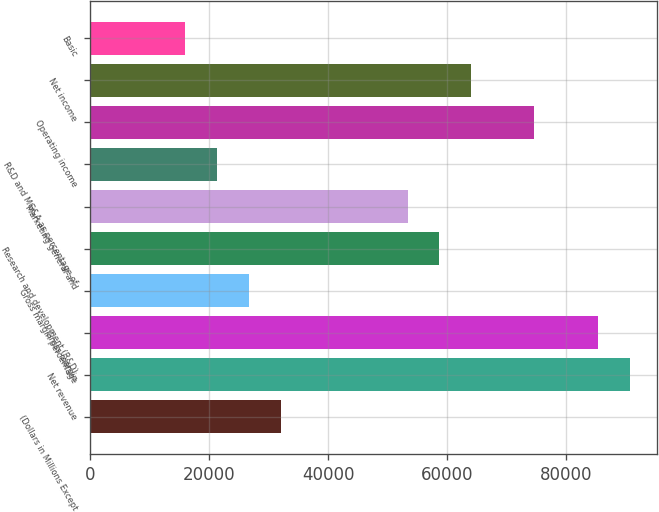Convert chart to OTSL. <chart><loc_0><loc_0><loc_500><loc_500><bar_chart><fcel>(Dollars in Millions Except<fcel>Net revenue<fcel>Gross margin<fcel>Gross margin percentage<fcel>Research and development (R&D)<fcel>Marketing general and<fcel>R&D and MG&A as percentage of<fcel>Operating income<fcel>Net income<fcel>Basic<nl><fcel>32004.9<fcel>90679<fcel>85345<fcel>26670.9<fcel>58675<fcel>53341<fcel>21336.9<fcel>74677<fcel>64009<fcel>16002.9<nl></chart> 